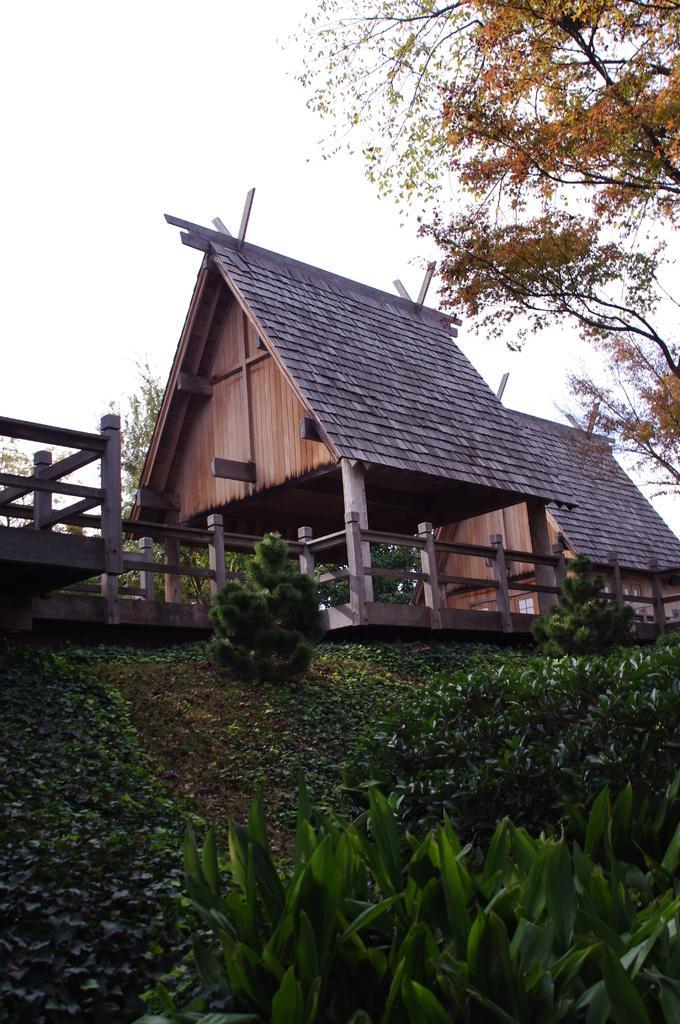Could you give a brief overview of what you see in this image? In the foreground of this image, there are plants. In the middle, there is railing, a hut like structure and a house behind it. On the right, there is a tree and at the top, there is the sky. 